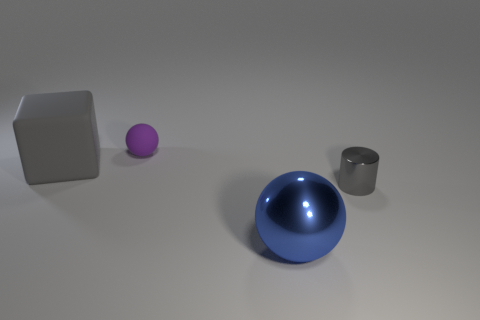Add 1 gray matte balls. How many objects exist? 5 Subtract all blocks. How many objects are left? 3 Subtract all blocks. Subtract all matte spheres. How many objects are left? 2 Add 2 small gray metal cylinders. How many small gray metal cylinders are left? 3 Add 1 big shiny things. How many big shiny things exist? 2 Subtract 0 yellow cylinders. How many objects are left? 4 